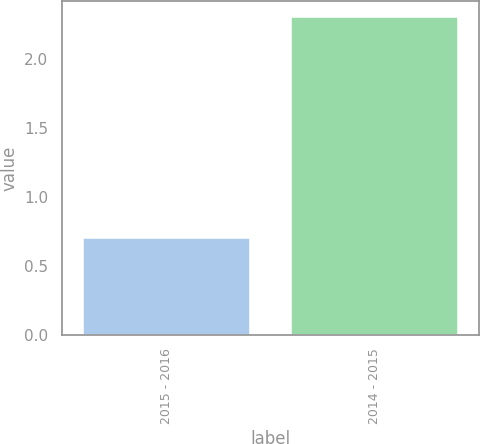Convert chart. <chart><loc_0><loc_0><loc_500><loc_500><bar_chart><fcel>2015 - 2016<fcel>2014 - 2015<nl><fcel>0.7<fcel>2.3<nl></chart> 